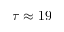Convert formula to latex. <formula><loc_0><loc_0><loc_500><loc_500>\tau \approx 1 9</formula> 